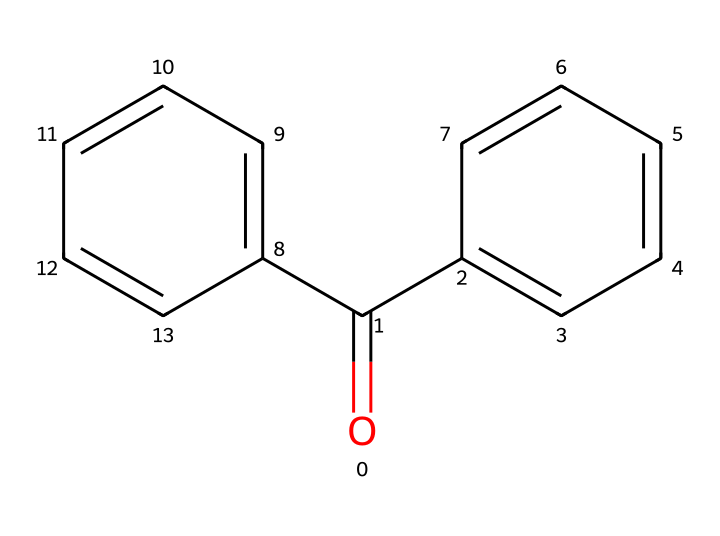What is the name of this chemical? The SMILES representation indicates a compound with a carbonyl group (O=C) attached to two phenyl rings (c1ccccc1). This structure matches the known chemical name benzophenone.
Answer: benzophenone How many carbon atoms are in benzophenone? By counting the 'c' and 'C' in the SMILES, there are 13 carbon atoms (11 in the rings and 2 in the carbonyl and connecting position).
Answer: 13 How many benzene rings are present in the structure? Each 'c1ccccc1' represents a benzene ring, and there are two instances of this in the SMILES. Thus, there are 2 benzene rings.
Answer: 2 What type of functional group is present in benzophenone? The carbonyl functional group (C=O) is present in the structure, which is characteristic of ketones.
Answer: ketone Is benzophenone considered aromatic? The presence of benzene rings indicates aromaticity, meaning the structure has delocalized π electrons and satisfies Huckel’s rule.
Answer: yes What is the molecular formula of benzophenone? By deducing from the counted atoms: C (13), H (10), O (1). Thus, the molecular formula is C13H10O.
Answer: C13H10O What reaction does benzophenone typically undergo? Benzophenone primarily undergoes nucleophilic addition due to the presence of the carbonyl group.
Answer: nucleophilic addition 